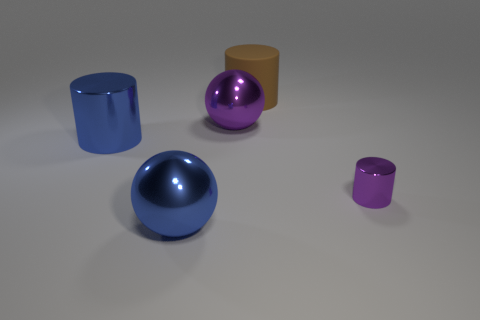Add 1 large blue metal objects. How many objects exist? 6 Subtract all blue metal cylinders. How many cylinders are left? 2 Subtract all cylinders. How many objects are left? 2 Subtract all purple cylinders. Subtract all blue blocks. How many cylinders are left? 2 Subtract all blue spheres. How many blue cylinders are left? 1 Subtract all brown things. Subtract all blue spheres. How many objects are left? 3 Add 2 cylinders. How many cylinders are left? 5 Add 5 large cylinders. How many large cylinders exist? 7 Subtract all blue cylinders. How many cylinders are left? 2 Subtract 0 yellow balls. How many objects are left? 5 